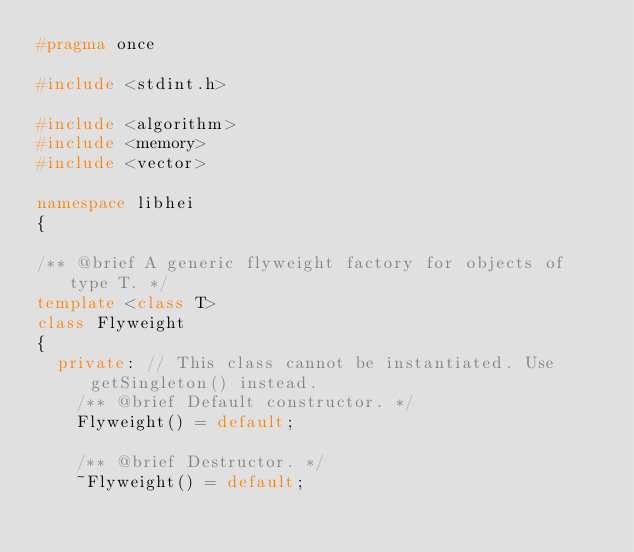<code> <loc_0><loc_0><loc_500><loc_500><_C++_>#pragma once

#include <stdint.h>

#include <algorithm>
#include <memory>
#include <vector>

namespace libhei
{

/** @brief A generic flyweight factory for objects of type T. */
template <class T>
class Flyweight
{
  private: // This class cannot be instantiated. Use getSingleton() instead.
    /** @brief Default constructor. */
    Flyweight() = default;

    /** @brief Destructor. */
    ~Flyweight() = default;
</code> 